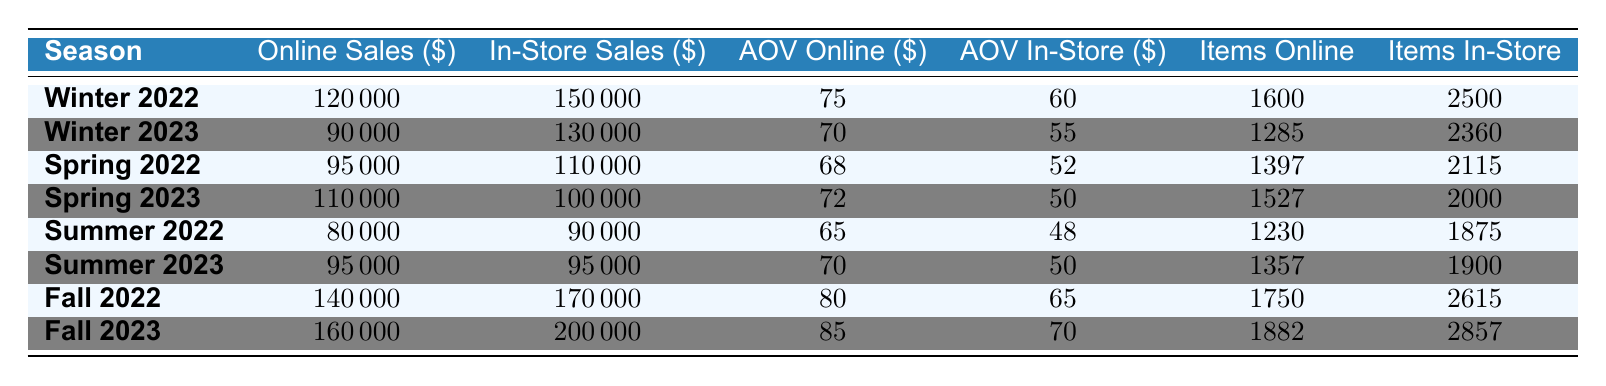What are the online sales for Winter 2022? From the table, we can directly locate the row for Winter 2022, which shows online sales amounting to $120,000.
Answer: 120000 What was the average order value for in-store sales in Fall 2023? Looking at the row for Fall 2023 in the table, the average order value for in-store sales is $70.
Answer: 70 How many items were sold online during Spring 2022? The table indicates that in the Spring 2022 row, the number of items sold online was 1,397.
Answer: 1397 Which season had the highest in-store sales? By comparing the in-store sales for all seasons, the Fall 2023 season shows the highest in-store sales at $200,000.
Answer: Fall 2023 What is the difference in online sales between Fall 2022 and Winter 2023? The online sales for Fall 2022 is $140,000 and for Winter 2023 is $90,000. The difference is $140,000 - $90,000 = $50,000.
Answer: 50000 Was the average order value for online sales higher in Winter 2022 compared to Spring 2023? Winter 2022 has an average order value of $75 for online sales, whereas Spring 2023 has $72. Since $75 > $72, it was higher.
Answer: Yes What is the total number of items sold in-store across all seasons? We sum the items sold in-store for each season: 2,500 (Winter 2022) + 2,360 (Winter 2023) + 2,115 (Spring 2022) + 2,000 (Spring 2023) + 1,875 (Summer 2022) + 1,900 (Summer 2023) + 2,615 (Fall 2022) + 2,857 (Fall 2023) =  18,422.
Answer: 18422 Which season saw an increase in online sales compared to the previous season? Analyzing the online sales for each season, Spring 2023 (110,000) compared to Spring 2022 (95,000) shows an increase of $15,000. No other season has shown an increase compared to its previous one.
Answer: Spring 2023 What was the percentage increase in online sales from Summer 2022 to Summer 2023? Online sales in Summer 2022 was $80,000 and in Summer 2023 was $95,000. The increase is $95,000 - $80,000 = $15,000. The percentage increase is ($15,000 / $80,000) * 100 = 18.75%.
Answer: 18.75% How did the average order value for in-store sales change from Winter 2022 to Winter 2023? The average order value for in-store sales was $60 in Winter 2022 and decreased to $55 in Winter 2023. This shows a change of $60 - $55 = $5.
Answer: Decreased by 5 